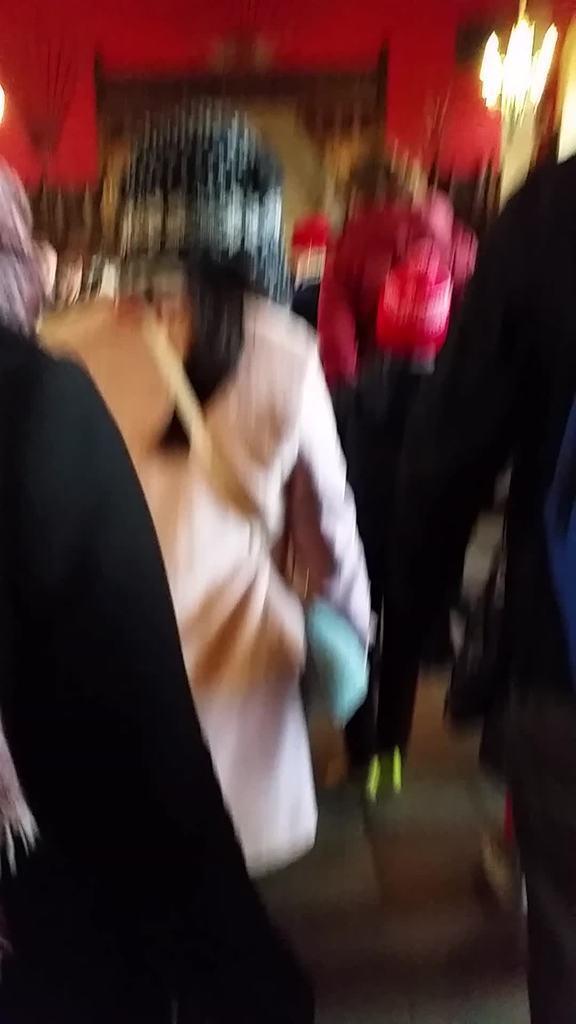Please provide a concise description of this image. In this picture I can see people, red color wall, lights and some other objects. This image is blurred. 